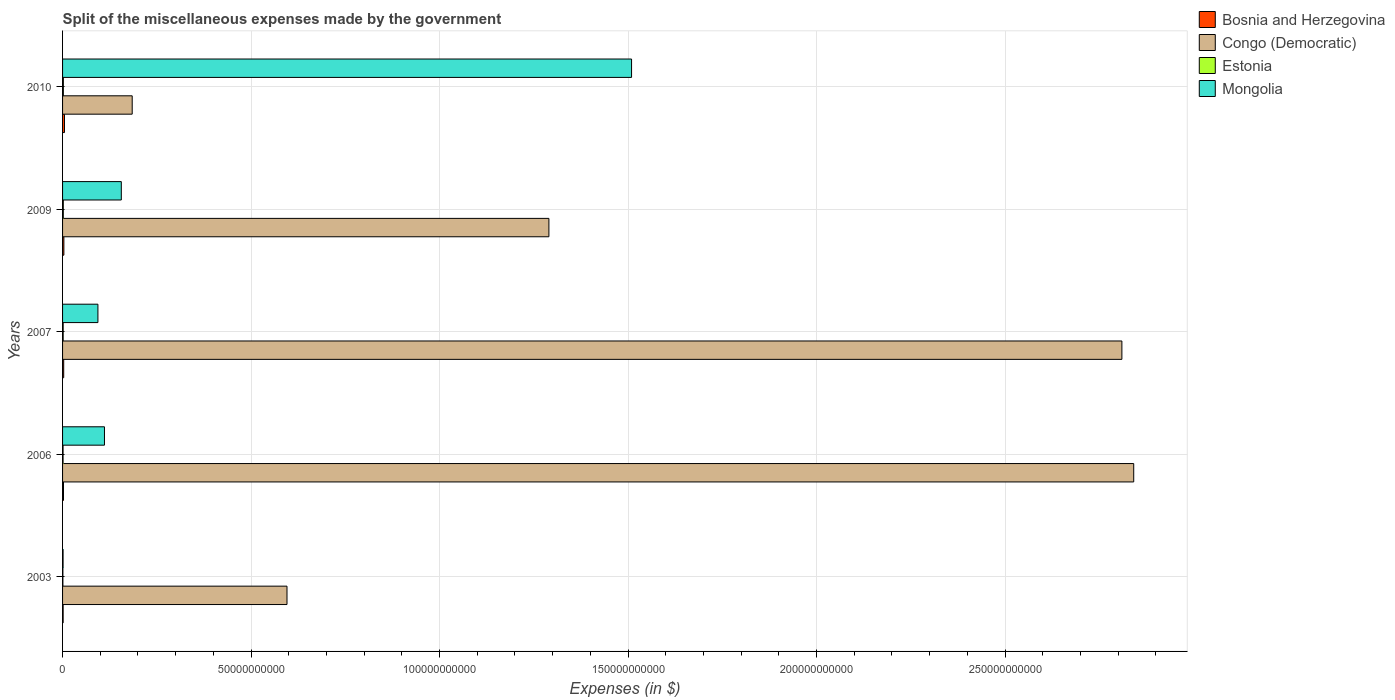How many different coloured bars are there?
Provide a succinct answer. 4. Are the number of bars on each tick of the Y-axis equal?
Your answer should be compact. Yes. In how many cases, is the number of bars for a given year not equal to the number of legend labels?
Provide a succinct answer. 0. What is the miscellaneous expenses made by the government in Congo (Democratic) in 2003?
Your answer should be compact. 5.95e+1. Across all years, what is the maximum miscellaneous expenses made by the government in Congo (Democratic)?
Offer a terse response. 2.84e+11. Across all years, what is the minimum miscellaneous expenses made by the government in Congo (Democratic)?
Keep it short and to the point. 1.85e+1. In which year was the miscellaneous expenses made by the government in Estonia minimum?
Give a very brief answer. 2003. What is the total miscellaneous expenses made by the government in Bosnia and Herzegovina in the graph?
Ensure brevity in your answer.  1.56e+09. What is the difference between the miscellaneous expenses made by the government in Bosnia and Herzegovina in 2003 and that in 2009?
Your answer should be compact. -1.96e+08. What is the difference between the miscellaneous expenses made by the government in Estonia in 2006 and the miscellaneous expenses made by the government in Mongolia in 2007?
Keep it short and to the point. -9.25e+09. What is the average miscellaneous expenses made by the government in Estonia per year?
Give a very brief answer. 1.57e+08. In the year 2009, what is the difference between the miscellaneous expenses made by the government in Mongolia and miscellaneous expenses made by the government in Estonia?
Provide a succinct answer. 1.54e+1. What is the ratio of the miscellaneous expenses made by the government in Bosnia and Herzegovina in 2006 to that in 2009?
Keep it short and to the point. 0.7. What is the difference between the highest and the second highest miscellaneous expenses made by the government in Bosnia and Herzegovina?
Provide a short and direct response. 1.58e+08. What is the difference between the highest and the lowest miscellaneous expenses made by the government in Bosnia and Herzegovina?
Provide a succinct answer. 3.54e+08. In how many years, is the miscellaneous expenses made by the government in Estonia greater than the average miscellaneous expenses made by the government in Estonia taken over all years?
Provide a short and direct response. 3. Is the sum of the miscellaneous expenses made by the government in Congo (Democratic) in 2006 and 2009 greater than the maximum miscellaneous expenses made by the government in Mongolia across all years?
Offer a terse response. Yes. Is it the case that in every year, the sum of the miscellaneous expenses made by the government in Estonia and miscellaneous expenses made by the government in Mongolia is greater than the sum of miscellaneous expenses made by the government in Bosnia and Herzegovina and miscellaneous expenses made by the government in Congo (Democratic)?
Offer a very short reply. Yes. What does the 4th bar from the top in 2006 represents?
Offer a very short reply. Bosnia and Herzegovina. What does the 2nd bar from the bottom in 2003 represents?
Make the answer very short. Congo (Democratic). Are all the bars in the graph horizontal?
Your answer should be very brief. Yes. What is the difference between two consecutive major ticks on the X-axis?
Provide a succinct answer. 5.00e+1. Does the graph contain any zero values?
Your answer should be very brief. No. Where does the legend appear in the graph?
Offer a terse response. Top right. How many legend labels are there?
Your response must be concise. 4. How are the legend labels stacked?
Your response must be concise. Vertical. What is the title of the graph?
Provide a succinct answer. Split of the miscellaneous expenses made by the government. What is the label or title of the X-axis?
Provide a short and direct response. Expenses (in $). What is the label or title of the Y-axis?
Give a very brief answer. Years. What is the Expenses (in $) in Bosnia and Herzegovina in 2003?
Ensure brevity in your answer.  1.53e+08. What is the Expenses (in $) in Congo (Democratic) in 2003?
Make the answer very short. 5.95e+1. What is the Expenses (in $) in Estonia in 2003?
Your answer should be compact. 8.66e+07. What is the Expenses (in $) of Mongolia in 2003?
Give a very brief answer. 1.35e+08. What is the Expenses (in $) in Bosnia and Herzegovina in 2006?
Give a very brief answer. 2.46e+08. What is the Expenses (in $) in Congo (Democratic) in 2006?
Make the answer very short. 2.84e+11. What is the Expenses (in $) of Estonia in 2006?
Your answer should be compact. 1.33e+08. What is the Expenses (in $) of Mongolia in 2006?
Provide a succinct answer. 1.11e+1. What is the Expenses (in $) of Bosnia and Herzegovina in 2007?
Your answer should be compact. 3.01e+08. What is the Expenses (in $) of Congo (Democratic) in 2007?
Provide a succinct answer. 2.81e+11. What is the Expenses (in $) of Estonia in 2007?
Keep it short and to the point. 1.60e+08. What is the Expenses (in $) of Mongolia in 2007?
Ensure brevity in your answer.  9.38e+09. What is the Expenses (in $) of Bosnia and Herzegovina in 2009?
Provide a short and direct response. 3.49e+08. What is the Expenses (in $) in Congo (Democratic) in 2009?
Provide a succinct answer. 1.29e+11. What is the Expenses (in $) in Estonia in 2009?
Your response must be concise. 1.95e+08. What is the Expenses (in $) in Mongolia in 2009?
Your answer should be very brief. 1.56e+1. What is the Expenses (in $) in Bosnia and Herzegovina in 2010?
Your answer should be very brief. 5.07e+08. What is the Expenses (in $) in Congo (Democratic) in 2010?
Ensure brevity in your answer.  1.85e+1. What is the Expenses (in $) of Estonia in 2010?
Give a very brief answer. 2.09e+08. What is the Expenses (in $) of Mongolia in 2010?
Give a very brief answer. 1.51e+11. Across all years, what is the maximum Expenses (in $) of Bosnia and Herzegovina?
Your response must be concise. 5.07e+08. Across all years, what is the maximum Expenses (in $) in Congo (Democratic)?
Ensure brevity in your answer.  2.84e+11. Across all years, what is the maximum Expenses (in $) in Estonia?
Your answer should be compact. 2.09e+08. Across all years, what is the maximum Expenses (in $) of Mongolia?
Your answer should be compact. 1.51e+11. Across all years, what is the minimum Expenses (in $) in Bosnia and Herzegovina?
Keep it short and to the point. 1.53e+08. Across all years, what is the minimum Expenses (in $) in Congo (Democratic)?
Make the answer very short. 1.85e+1. Across all years, what is the minimum Expenses (in $) of Estonia?
Make the answer very short. 8.66e+07. Across all years, what is the minimum Expenses (in $) of Mongolia?
Give a very brief answer. 1.35e+08. What is the total Expenses (in $) in Bosnia and Herzegovina in the graph?
Provide a succinct answer. 1.56e+09. What is the total Expenses (in $) in Congo (Democratic) in the graph?
Offer a very short reply. 7.72e+11. What is the total Expenses (in $) of Estonia in the graph?
Ensure brevity in your answer.  7.83e+08. What is the total Expenses (in $) of Mongolia in the graph?
Keep it short and to the point. 1.87e+11. What is the difference between the Expenses (in $) of Bosnia and Herzegovina in 2003 and that in 2006?
Make the answer very short. -9.25e+07. What is the difference between the Expenses (in $) in Congo (Democratic) in 2003 and that in 2006?
Offer a terse response. -2.25e+11. What is the difference between the Expenses (in $) of Estonia in 2003 and that in 2006?
Your answer should be very brief. -4.62e+07. What is the difference between the Expenses (in $) of Mongolia in 2003 and that in 2006?
Your answer should be compact. -1.10e+1. What is the difference between the Expenses (in $) of Bosnia and Herzegovina in 2003 and that in 2007?
Keep it short and to the point. -1.48e+08. What is the difference between the Expenses (in $) in Congo (Democratic) in 2003 and that in 2007?
Offer a terse response. -2.21e+11. What is the difference between the Expenses (in $) of Estonia in 2003 and that in 2007?
Ensure brevity in your answer.  -7.30e+07. What is the difference between the Expenses (in $) in Mongolia in 2003 and that in 2007?
Make the answer very short. -9.25e+09. What is the difference between the Expenses (in $) of Bosnia and Herzegovina in 2003 and that in 2009?
Ensure brevity in your answer.  -1.96e+08. What is the difference between the Expenses (in $) in Congo (Democratic) in 2003 and that in 2009?
Ensure brevity in your answer.  -6.95e+1. What is the difference between the Expenses (in $) in Estonia in 2003 and that in 2009?
Your response must be concise. -1.08e+08. What is the difference between the Expenses (in $) in Mongolia in 2003 and that in 2009?
Your answer should be compact. -1.55e+1. What is the difference between the Expenses (in $) in Bosnia and Herzegovina in 2003 and that in 2010?
Your answer should be very brief. -3.54e+08. What is the difference between the Expenses (in $) of Congo (Democratic) in 2003 and that in 2010?
Offer a very short reply. 4.11e+1. What is the difference between the Expenses (in $) in Estonia in 2003 and that in 2010?
Offer a very short reply. -1.23e+08. What is the difference between the Expenses (in $) in Mongolia in 2003 and that in 2010?
Ensure brevity in your answer.  -1.51e+11. What is the difference between the Expenses (in $) of Bosnia and Herzegovina in 2006 and that in 2007?
Offer a very short reply. -5.57e+07. What is the difference between the Expenses (in $) in Congo (Democratic) in 2006 and that in 2007?
Provide a short and direct response. 3.14e+09. What is the difference between the Expenses (in $) of Estonia in 2006 and that in 2007?
Your answer should be very brief. -2.68e+07. What is the difference between the Expenses (in $) in Mongolia in 2006 and that in 2007?
Keep it short and to the point. 1.74e+09. What is the difference between the Expenses (in $) of Bosnia and Herzegovina in 2006 and that in 2009?
Keep it short and to the point. -1.03e+08. What is the difference between the Expenses (in $) of Congo (Democratic) in 2006 and that in 2009?
Your response must be concise. 1.55e+11. What is the difference between the Expenses (in $) in Estonia in 2006 and that in 2009?
Your response must be concise. -6.21e+07. What is the difference between the Expenses (in $) of Mongolia in 2006 and that in 2009?
Provide a succinct answer. -4.47e+09. What is the difference between the Expenses (in $) in Bosnia and Herzegovina in 2006 and that in 2010?
Your response must be concise. -2.61e+08. What is the difference between the Expenses (in $) of Congo (Democratic) in 2006 and that in 2010?
Keep it short and to the point. 2.66e+11. What is the difference between the Expenses (in $) of Estonia in 2006 and that in 2010?
Your answer should be very brief. -7.65e+07. What is the difference between the Expenses (in $) of Mongolia in 2006 and that in 2010?
Keep it short and to the point. -1.40e+11. What is the difference between the Expenses (in $) in Bosnia and Herzegovina in 2007 and that in 2009?
Keep it short and to the point. -4.74e+07. What is the difference between the Expenses (in $) of Congo (Democratic) in 2007 and that in 2009?
Your answer should be compact. 1.52e+11. What is the difference between the Expenses (in $) in Estonia in 2007 and that in 2009?
Your response must be concise. -3.53e+07. What is the difference between the Expenses (in $) of Mongolia in 2007 and that in 2009?
Your answer should be very brief. -6.21e+09. What is the difference between the Expenses (in $) in Bosnia and Herzegovina in 2007 and that in 2010?
Ensure brevity in your answer.  -2.06e+08. What is the difference between the Expenses (in $) of Congo (Democratic) in 2007 and that in 2010?
Ensure brevity in your answer.  2.63e+11. What is the difference between the Expenses (in $) of Estonia in 2007 and that in 2010?
Give a very brief answer. -4.97e+07. What is the difference between the Expenses (in $) of Mongolia in 2007 and that in 2010?
Provide a short and direct response. -1.42e+11. What is the difference between the Expenses (in $) in Bosnia and Herzegovina in 2009 and that in 2010?
Offer a terse response. -1.58e+08. What is the difference between the Expenses (in $) in Congo (Democratic) in 2009 and that in 2010?
Provide a succinct answer. 1.11e+11. What is the difference between the Expenses (in $) in Estonia in 2009 and that in 2010?
Your response must be concise. -1.44e+07. What is the difference between the Expenses (in $) in Mongolia in 2009 and that in 2010?
Ensure brevity in your answer.  -1.35e+11. What is the difference between the Expenses (in $) in Bosnia and Herzegovina in 2003 and the Expenses (in $) in Congo (Democratic) in 2006?
Ensure brevity in your answer.  -2.84e+11. What is the difference between the Expenses (in $) in Bosnia and Herzegovina in 2003 and the Expenses (in $) in Estonia in 2006?
Make the answer very short. 2.04e+07. What is the difference between the Expenses (in $) in Bosnia and Herzegovina in 2003 and the Expenses (in $) in Mongolia in 2006?
Your answer should be compact. -1.10e+1. What is the difference between the Expenses (in $) of Congo (Democratic) in 2003 and the Expenses (in $) of Estonia in 2006?
Give a very brief answer. 5.94e+1. What is the difference between the Expenses (in $) in Congo (Democratic) in 2003 and the Expenses (in $) in Mongolia in 2006?
Offer a terse response. 4.84e+1. What is the difference between the Expenses (in $) in Estonia in 2003 and the Expenses (in $) in Mongolia in 2006?
Your answer should be compact. -1.10e+1. What is the difference between the Expenses (in $) of Bosnia and Herzegovina in 2003 and the Expenses (in $) of Congo (Democratic) in 2007?
Provide a succinct answer. -2.81e+11. What is the difference between the Expenses (in $) in Bosnia and Herzegovina in 2003 and the Expenses (in $) in Estonia in 2007?
Your response must be concise. -6.40e+06. What is the difference between the Expenses (in $) of Bosnia and Herzegovina in 2003 and the Expenses (in $) of Mongolia in 2007?
Your answer should be very brief. -9.23e+09. What is the difference between the Expenses (in $) of Congo (Democratic) in 2003 and the Expenses (in $) of Estonia in 2007?
Ensure brevity in your answer.  5.94e+1. What is the difference between the Expenses (in $) of Congo (Democratic) in 2003 and the Expenses (in $) of Mongolia in 2007?
Keep it short and to the point. 5.02e+1. What is the difference between the Expenses (in $) of Estonia in 2003 and the Expenses (in $) of Mongolia in 2007?
Your answer should be compact. -9.29e+09. What is the difference between the Expenses (in $) in Bosnia and Herzegovina in 2003 and the Expenses (in $) in Congo (Democratic) in 2009?
Your response must be concise. -1.29e+11. What is the difference between the Expenses (in $) in Bosnia and Herzegovina in 2003 and the Expenses (in $) in Estonia in 2009?
Make the answer very short. -4.17e+07. What is the difference between the Expenses (in $) in Bosnia and Herzegovina in 2003 and the Expenses (in $) in Mongolia in 2009?
Offer a very short reply. -1.54e+1. What is the difference between the Expenses (in $) of Congo (Democratic) in 2003 and the Expenses (in $) of Estonia in 2009?
Keep it short and to the point. 5.93e+1. What is the difference between the Expenses (in $) of Congo (Democratic) in 2003 and the Expenses (in $) of Mongolia in 2009?
Your answer should be very brief. 4.39e+1. What is the difference between the Expenses (in $) in Estonia in 2003 and the Expenses (in $) in Mongolia in 2009?
Provide a succinct answer. -1.55e+1. What is the difference between the Expenses (in $) in Bosnia and Herzegovina in 2003 and the Expenses (in $) in Congo (Democratic) in 2010?
Give a very brief answer. -1.83e+1. What is the difference between the Expenses (in $) of Bosnia and Herzegovina in 2003 and the Expenses (in $) of Estonia in 2010?
Ensure brevity in your answer.  -5.61e+07. What is the difference between the Expenses (in $) in Bosnia and Herzegovina in 2003 and the Expenses (in $) in Mongolia in 2010?
Offer a terse response. -1.51e+11. What is the difference between the Expenses (in $) in Congo (Democratic) in 2003 and the Expenses (in $) in Estonia in 2010?
Your response must be concise. 5.93e+1. What is the difference between the Expenses (in $) of Congo (Democratic) in 2003 and the Expenses (in $) of Mongolia in 2010?
Your response must be concise. -9.14e+1. What is the difference between the Expenses (in $) of Estonia in 2003 and the Expenses (in $) of Mongolia in 2010?
Your answer should be compact. -1.51e+11. What is the difference between the Expenses (in $) of Bosnia and Herzegovina in 2006 and the Expenses (in $) of Congo (Democratic) in 2007?
Keep it short and to the point. -2.81e+11. What is the difference between the Expenses (in $) in Bosnia and Herzegovina in 2006 and the Expenses (in $) in Estonia in 2007?
Provide a short and direct response. 8.61e+07. What is the difference between the Expenses (in $) in Bosnia and Herzegovina in 2006 and the Expenses (in $) in Mongolia in 2007?
Offer a terse response. -9.13e+09. What is the difference between the Expenses (in $) in Congo (Democratic) in 2006 and the Expenses (in $) in Estonia in 2007?
Your answer should be very brief. 2.84e+11. What is the difference between the Expenses (in $) in Congo (Democratic) in 2006 and the Expenses (in $) in Mongolia in 2007?
Your answer should be compact. 2.75e+11. What is the difference between the Expenses (in $) of Estonia in 2006 and the Expenses (in $) of Mongolia in 2007?
Keep it short and to the point. -9.25e+09. What is the difference between the Expenses (in $) of Bosnia and Herzegovina in 2006 and the Expenses (in $) of Congo (Democratic) in 2009?
Provide a succinct answer. -1.29e+11. What is the difference between the Expenses (in $) of Bosnia and Herzegovina in 2006 and the Expenses (in $) of Estonia in 2009?
Ensure brevity in your answer.  5.08e+07. What is the difference between the Expenses (in $) of Bosnia and Herzegovina in 2006 and the Expenses (in $) of Mongolia in 2009?
Your response must be concise. -1.53e+1. What is the difference between the Expenses (in $) of Congo (Democratic) in 2006 and the Expenses (in $) of Estonia in 2009?
Your response must be concise. 2.84e+11. What is the difference between the Expenses (in $) of Congo (Democratic) in 2006 and the Expenses (in $) of Mongolia in 2009?
Offer a terse response. 2.69e+11. What is the difference between the Expenses (in $) of Estonia in 2006 and the Expenses (in $) of Mongolia in 2009?
Keep it short and to the point. -1.55e+1. What is the difference between the Expenses (in $) of Bosnia and Herzegovina in 2006 and the Expenses (in $) of Congo (Democratic) in 2010?
Provide a short and direct response. -1.82e+1. What is the difference between the Expenses (in $) in Bosnia and Herzegovina in 2006 and the Expenses (in $) in Estonia in 2010?
Your answer should be very brief. 3.64e+07. What is the difference between the Expenses (in $) of Bosnia and Herzegovina in 2006 and the Expenses (in $) of Mongolia in 2010?
Your response must be concise. -1.51e+11. What is the difference between the Expenses (in $) of Congo (Democratic) in 2006 and the Expenses (in $) of Estonia in 2010?
Offer a very short reply. 2.84e+11. What is the difference between the Expenses (in $) of Congo (Democratic) in 2006 and the Expenses (in $) of Mongolia in 2010?
Give a very brief answer. 1.33e+11. What is the difference between the Expenses (in $) of Estonia in 2006 and the Expenses (in $) of Mongolia in 2010?
Give a very brief answer. -1.51e+11. What is the difference between the Expenses (in $) in Bosnia and Herzegovina in 2007 and the Expenses (in $) in Congo (Democratic) in 2009?
Provide a short and direct response. -1.29e+11. What is the difference between the Expenses (in $) of Bosnia and Herzegovina in 2007 and the Expenses (in $) of Estonia in 2009?
Offer a very short reply. 1.06e+08. What is the difference between the Expenses (in $) in Bosnia and Herzegovina in 2007 and the Expenses (in $) in Mongolia in 2009?
Make the answer very short. -1.53e+1. What is the difference between the Expenses (in $) in Congo (Democratic) in 2007 and the Expenses (in $) in Estonia in 2009?
Make the answer very short. 2.81e+11. What is the difference between the Expenses (in $) of Congo (Democratic) in 2007 and the Expenses (in $) of Mongolia in 2009?
Your answer should be very brief. 2.65e+11. What is the difference between the Expenses (in $) in Estonia in 2007 and the Expenses (in $) in Mongolia in 2009?
Provide a short and direct response. -1.54e+1. What is the difference between the Expenses (in $) in Bosnia and Herzegovina in 2007 and the Expenses (in $) in Congo (Democratic) in 2010?
Your answer should be compact. -1.82e+1. What is the difference between the Expenses (in $) of Bosnia and Herzegovina in 2007 and the Expenses (in $) of Estonia in 2010?
Your response must be concise. 9.21e+07. What is the difference between the Expenses (in $) of Bosnia and Herzegovina in 2007 and the Expenses (in $) of Mongolia in 2010?
Your answer should be compact. -1.51e+11. What is the difference between the Expenses (in $) of Congo (Democratic) in 2007 and the Expenses (in $) of Estonia in 2010?
Ensure brevity in your answer.  2.81e+11. What is the difference between the Expenses (in $) in Congo (Democratic) in 2007 and the Expenses (in $) in Mongolia in 2010?
Provide a succinct answer. 1.30e+11. What is the difference between the Expenses (in $) in Estonia in 2007 and the Expenses (in $) in Mongolia in 2010?
Provide a succinct answer. -1.51e+11. What is the difference between the Expenses (in $) in Bosnia and Herzegovina in 2009 and the Expenses (in $) in Congo (Democratic) in 2010?
Offer a terse response. -1.81e+1. What is the difference between the Expenses (in $) of Bosnia and Herzegovina in 2009 and the Expenses (in $) of Estonia in 2010?
Offer a terse response. 1.40e+08. What is the difference between the Expenses (in $) in Bosnia and Herzegovina in 2009 and the Expenses (in $) in Mongolia in 2010?
Your answer should be compact. -1.51e+11. What is the difference between the Expenses (in $) of Congo (Democratic) in 2009 and the Expenses (in $) of Estonia in 2010?
Make the answer very short. 1.29e+11. What is the difference between the Expenses (in $) in Congo (Democratic) in 2009 and the Expenses (in $) in Mongolia in 2010?
Your response must be concise. -2.19e+1. What is the difference between the Expenses (in $) in Estonia in 2009 and the Expenses (in $) in Mongolia in 2010?
Make the answer very short. -1.51e+11. What is the average Expenses (in $) in Bosnia and Herzegovina per year?
Your response must be concise. 3.11e+08. What is the average Expenses (in $) in Congo (Democratic) per year?
Keep it short and to the point. 1.54e+11. What is the average Expenses (in $) of Estonia per year?
Keep it short and to the point. 1.57e+08. What is the average Expenses (in $) of Mongolia per year?
Make the answer very short. 3.74e+1. In the year 2003, what is the difference between the Expenses (in $) of Bosnia and Herzegovina and Expenses (in $) of Congo (Democratic)?
Ensure brevity in your answer.  -5.94e+1. In the year 2003, what is the difference between the Expenses (in $) in Bosnia and Herzegovina and Expenses (in $) in Estonia?
Keep it short and to the point. 6.66e+07. In the year 2003, what is the difference between the Expenses (in $) in Bosnia and Herzegovina and Expenses (in $) in Mongolia?
Ensure brevity in your answer.  1.83e+07. In the year 2003, what is the difference between the Expenses (in $) in Congo (Democratic) and Expenses (in $) in Estonia?
Ensure brevity in your answer.  5.94e+1. In the year 2003, what is the difference between the Expenses (in $) in Congo (Democratic) and Expenses (in $) in Mongolia?
Offer a terse response. 5.94e+1. In the year 2003, what is the difference between the Expenses (in $) in Estonia and Expenses (in $) in Mongolia?
Your answer should be very brief. -4.83e+07. In the year 2006, what is the difference between the Expenses (in $) in Bosnia and Herzegovina and Expenses (in $) in Congo (Democratic)?
Offer a very short reply. -2.84e+11. In the year 2006, what is the difference between the Expenses (in $) in Bosnia and Herzegovina and Expenses (in $) in Estonia?
Your answer should be very brief. 1.13e+08. In the year 2006, what is the difference between the Expenses (in $) in Bosnia and Herzegovina and Expenses (in $) in Mongolia?
Your answer should be compact. -1.09e+1. In the year 2006, what is the difference between the Expenses (in $) of Congo (Democratic) and Expenses (in $) of Estonia?
Your response must be concise. 2.84e+11. In the year 2006, what is the difference between the Expenses (in $) in Congo (Democratic) and Expenses (in $) in Mongolia?
Your answer should be compact. 2.73e+11. In the year 2006, what is the difference between the Expenses (in $) in Estonia and Expenses (in $) in Mongolia?
Make the answer very short. -1.10e+1. In the year 2007, what is the difference between the Expenses (in $) of Bosnia and Herzegovina and Expenses (in $) of Congo (Democratic)?
Your answer should be very brief. -2.81e+11. In the year 2007, what is the difference between the Expenses (in $) of Bosnia and Herzegovina and Expenses (in $) of Estonia?
Your response must be concise. 1.42e+08. In the year 2007, what is the difference between the Expenses (in $) of Bosnia and Herzegovina and Expenses (in $) of Mongolia?
Offer a very short reply. -9.08e+09. In the year 2007, what is the difference between the Expenses (in $) in Congo (Democratic) and Expenses (in $) in Estonia?
Make the answer very short. 2.81e+11. In the year 2007, what is the difference between the Expenses (in $) of Congo (Democratic) and Expenses (in $) of Mongolia?
Your response must be concise. 2.72e+11. In the year 2007, what is the difference between the Expenses (in $) of Estonia and Expenses (in $) of Mongolia?
Make the answer very short. -9.22e+09. In the year 2009, what is the difference between the Expenses (in $) in Bosnia and Herzegovina and Expenses (in $) in Congo (Democratic)?
Make the answer very short. -1.29e+11. In the year 2009, what is the difference between the Expenses (in $) of Bosnia and Herzegovina and Expenses (in $) of Estonia?
Offer a very short reply. 1.54e+08. In the year 2009, what is the difference between the Expenses (in $) in Bosnia and Herzegovina and Expenses (in $) in Mongolia?
Provide a succinct answer. -1.52e+1. In the year 2009, what is the difference between the Expenses (in $) of Congo (Democratic) and Expenses (in $) of Estonia?
Provide a short and direct response. 1.29e+11. In the year 2009, what is the difference between the Expenses (in $) of Congo (Democratic) and Expenses (in $) of Mongolia?
Your answer should be compact. 1.13e+11. In the year 2009, what is the difference between the Expenses (in $) of Estonia and Expenses (in $) of Mongolia?
Your response must be concise. -1.54e+1. In the year 2010, what is the difference between the Expenses (in $) in Bosnia and Herzegovina and Expenses (in $) in Congo (Democratic)?
Your answer should be compact. -1.80e+1. In the year 2010, what is the difference between the Expenses (in $) of Bosnia and Herzegovina and Expenses (in $) of Estonia?
Offer a very short reply. 2.98e+08. In the year 2010, what is the difference between the Expenses (in $) in Bosnia and Herzegovina and Expenses (in $) in Mongolia?
Your response must be concise. -1.50e+11. In the year 2010, what is the difference between the Expenses (in $) of Congo (Democratic) and Expenses (in $) of Estonia?
Offer a very short reply. 1.83e+1. In the year 2010, what is the difference between the Expenses (in $) of Congo (Democratic) and Expenses (in $) of Mongolia?
Provide a succinct answer. -1.32e+11. In the year 2010, what is the difference between the Expenses (in $) of Estonia and Expenses (in $) of Mongolia?
Keep it short and to the point. -1.51e+11. What is the ratio of the Expenses (in $) of Bosnia and Herzegovina in 2003 to that in 2006?
Ensure brevity in your answer.  0.62. What is the ratio of the Expenses (in $) of Congo (Democratic) in 2003 to that in 2006?
Offer a very short reply. 0.21. What is the ratio of the Expenses (in $) in Estonia in 2003 to that in 2006?
Keep it short and to the point. 0.65. What is the ratio of the Expenses (in $) in Mongolia in 2003 to that in 2006?
Your answer should be very brief. 0.01. What is the ratio of the Expenses (in $) of Bosnia and Herzegovina in 2003 to that in 2007?
Give a very brief answer. 0.51. What is the ratio of the Expenses (in $) of Congo (Democratic) in 2003 to that in 2007?
Your answer should be compact. 0.21. What is the ratio of the Expenses (in $) of Estonia in 2003 to that in 2007?
Your response must be concise. 0.54. What is the ratio of the Expenses (in $) in Mongolia in 2003 to that in 2007?
Give a very brief answer. 0.01. What is the ratio of the Expenses (in $) in Bosnia and Herzegovina in 2003 to that in 2009?
Make the answer very short. 0.44. What is the ratio of the Expenses (in $) in Congo (Democratic) in 2003 to that in 2009?
Ensure brevity in your answer.  0.46. What is the ratio of the Expenses (in $) in Estonia in 2003 to that in 2009?
Provide a short and direct response. 0.44. What is the ratio of the Expenses (in $) in Mongolia in 2003 to that in 2009?
Your answer should be very brief. 0.01. What is the ratio of the Expenses (in $) in Bosnia and Herzegovina in 2003 to that in 2010?
Keep it short and to the point. 0.3. What is the ratio of the Expenses (in $) of Congo (Democratic) in 2003 to that in 2010?
Your response must be concise. 3.22. What is the ratio of the Expenses (in $) in Estonia in 2003 to that in 2010?
Keep it short and to the point. 0.41. What is the ratio of the Expenses (in $) of Mongolia in 2003 to that in 2010?
Make the answer very short. 0. What is the ratio of the Expenses (in $) of Bosnia and Herzegovina in 2006 to that in 2007?
Provide a succinct answer. 0.82. What is the ratio of the Expenses (in $) in Congo (Democratic) in 2006 to that in 2007?
Your answer should be compact. 1.01. What is the ratio of the Expenses (in $) of Estonia in 2006 to that in 2007?
Give a very brief answer. 0.83. What is the ratio of the Expenses (in $) in Mongolia in 2006 to that in 2007?
Offer a terse response. 1.19. What is the ratio of the Expenses (in $) in Bosnia and Herzegovina in 2006 to that in 2009?
Your response must be concise. 0.7. What is the ratio of the Expenses (in $) of Congo (Democratic) in 2006 to that in 2009?
Offer a very short reply. 2.2. What is the ratio of the Expenses (in $) in Estonia in 2006 to that in 2009?
Offer a terse response. 0.68. What is the ratio of the Expenses (in $) of Mongolia in 2006 to that in 2009?
Offer a very short reply. 0.71. What is the ratio of the Expenses (in $) of Bosnia and Herzegovina in 2006 to that in 2010?
Make the answer very short. 0.48. What is the ratio of the Expenses (in $) of Congo (Democratic) in 2006 to that in 2010?
Offer a terse response. 15.38. What is the ratio of the Expenses (in $) of Estonia in 2006 to that in 2010?
Offer a terse response. 0.63. What is the ratio of the Expenses (in $) in Mongolia in 2006 to that in 2010?
Your answer should be very brief. 0.07. What is the ratio of the Expenses (in $) in Bosnia and Herzegovina in 2007 to that in 2009?
Offer a very short reply. 0.86. What is the ratio of the Expenses (in $) in Congo (Democratic) in 2007 to that in 2009?
Offer a very short reply. 2.18. What is the ratio of the Expenses (in $) in Estonia in 2007 to that in 2009?
Your answer should be very brief. 0.82. What is the ratio of the Expenses (in $) in Mongolia in 2007 to that in 2009?
Make the answer very short. 0.6. What is the ratio of the Expenses (in $) in Bosnia and Herzegovina in 2007 to that in 2010?
Keep it short and to the point. 0.59. What is the ratio of the Expenses (in $) in Congo (Democratic) in 2007 to that in 2010?
Keep it short and to the point. 15.21. What is the ratio of the Expenses (in $) of Estonia in 2007 to that in 2010?
Your answer should be compact. 0.76. What is the ratio of the Expenses (in $) of Mongolia in 2007 to that in 2010?
Provide a short and direct response. 0.06. What is the ratio of the Expenses (in $) in Bosnia and Herzegovina in 2009 to that in 2010?
Your response must be concise. 0.69. What is the ratio of the Expenses (in $) in Congo (Democratic) in 2009 to that in 2010?
Offer a very short reply. 6.98. What is the ratio of the Expenses (in $) of Estonia in 2009 to that in 2010?
Make the answer very short. 0.93. What is the ratio of the Expenses (in $) in Mongolia in 2009 to that in 2010?
Ensure brevity in your answer.  0.1. What is the difference between the highest and the second highest Expenses (in $) in Bosnia and Herzegovina?
Provide a succinct answer. 1.58e+08. What is the difference between the highest and the second highest Expenses (in $) in Congo (Democratic)?
Provide a succinct answer. 3.14e+09. What is the difference between the highest and the second highest Expenses (in $) of Estonia?
Offer a very short reply. 1.44e+07. What is the difference between the highest and the second highest Expenses (in $) of Mongolia?
Provide a succinct answer. 1.35e+11. What is the difference between the highest and the lowest Expenses (in $) in Bosnia and Herzegovina?
Your answer should be very brief. 3.54e+08. What is the difference between the highest and the lowest Expenses (in $) of Congo (Democratic)?
Offer a terse response. 2.66e+11. What is the difference between the highest and the lowest Expenses (in $) in Estonia?
Your answer should be compact. 1.23e+08. What is the difference between the highest and the lowest Expenses (in $) of Mongolia?
Give a very brief answer. 1.51e+11. 